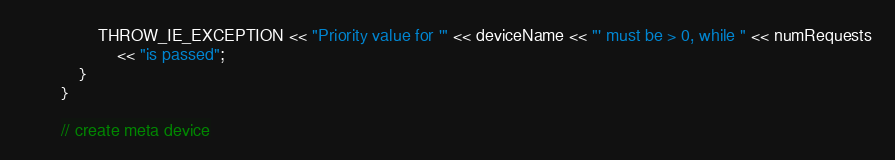<code> <loc_0><loc_0><loc_500><loc_500><_C++_>                THROW_IE_EXCEPTION << "Priority value for '" << deviceName << "' must be > 0, while " << numRequests
                    << "is passed";
            }
        }

        // create meta device</code> 